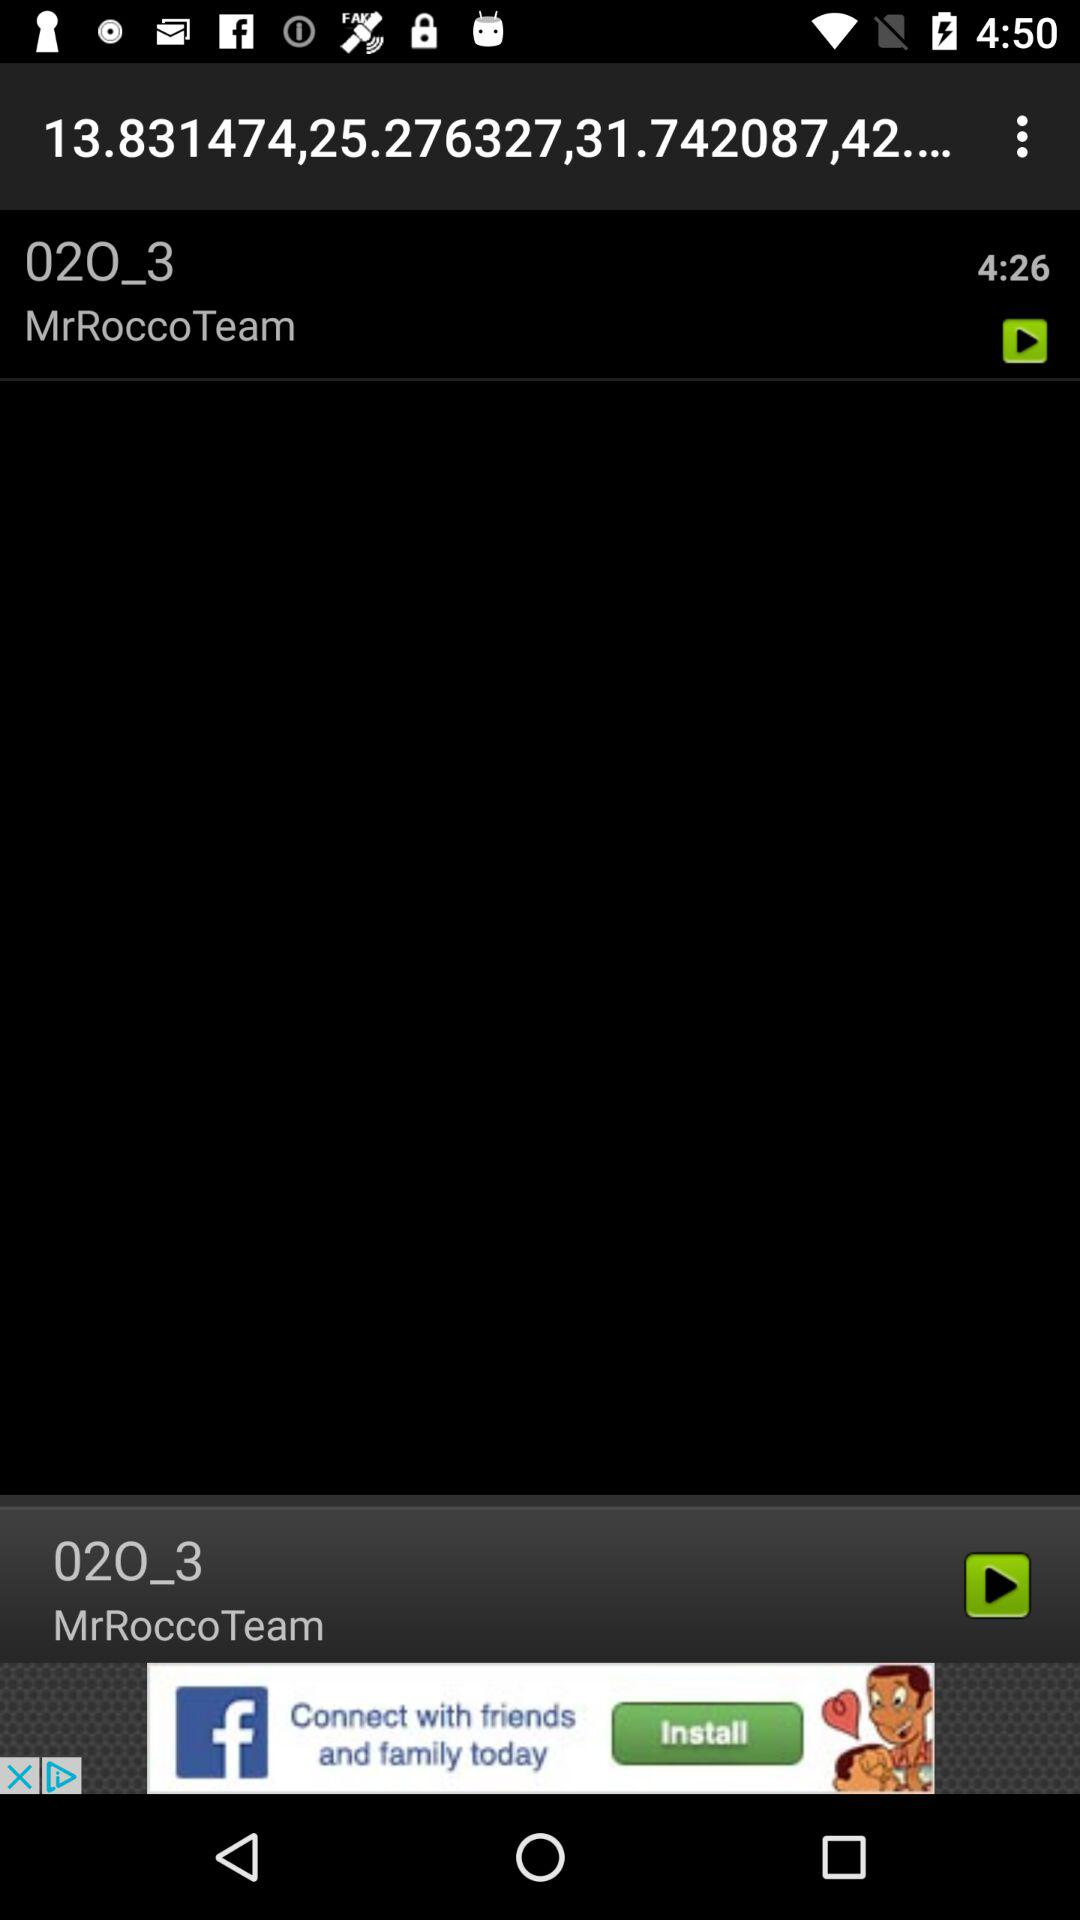What is the name of the application?
When the provided information is insufficient, respond with <no answer>. <no answer> 